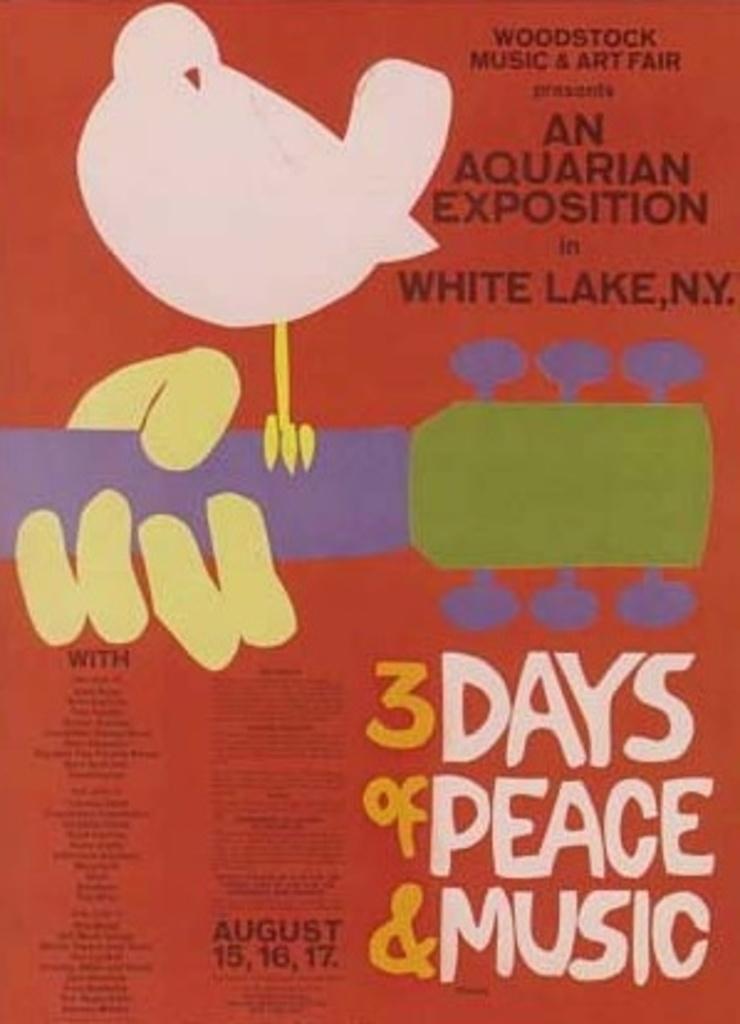In one or two sentences, can you explain what this image depicts? This is a poster. I can see a person's hand holding a guitar. This is the bird standing on the guitar. These are the letters. 